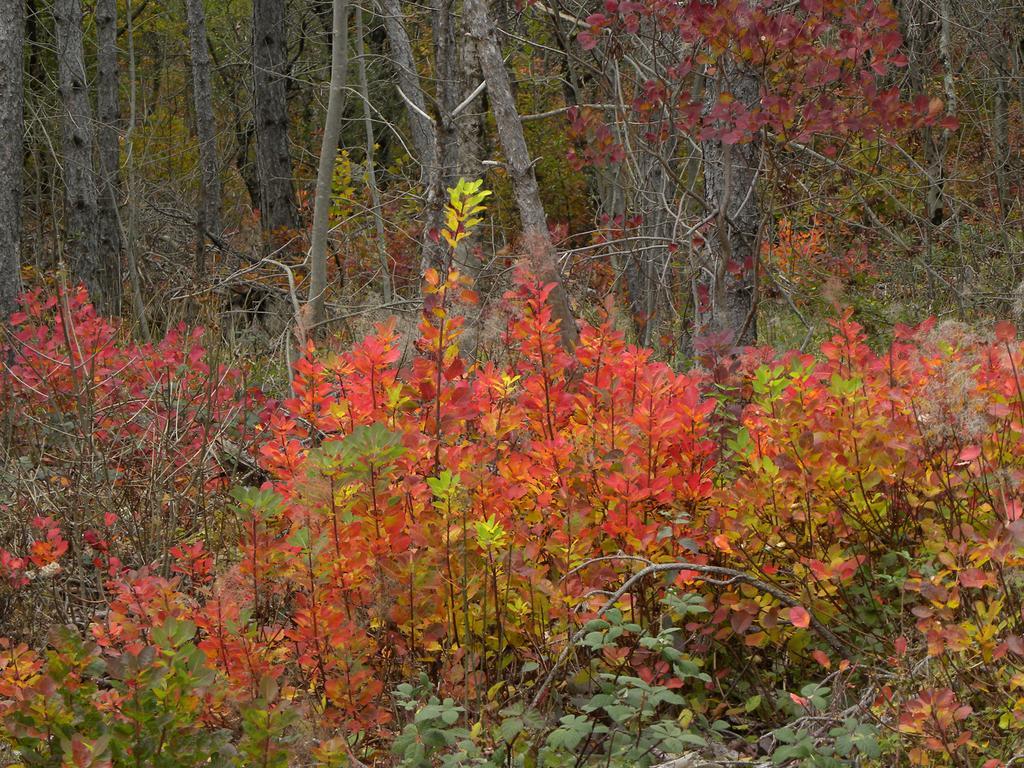Describe this image in one or two sentences. In the foreground of this image, there are plants and trees. 